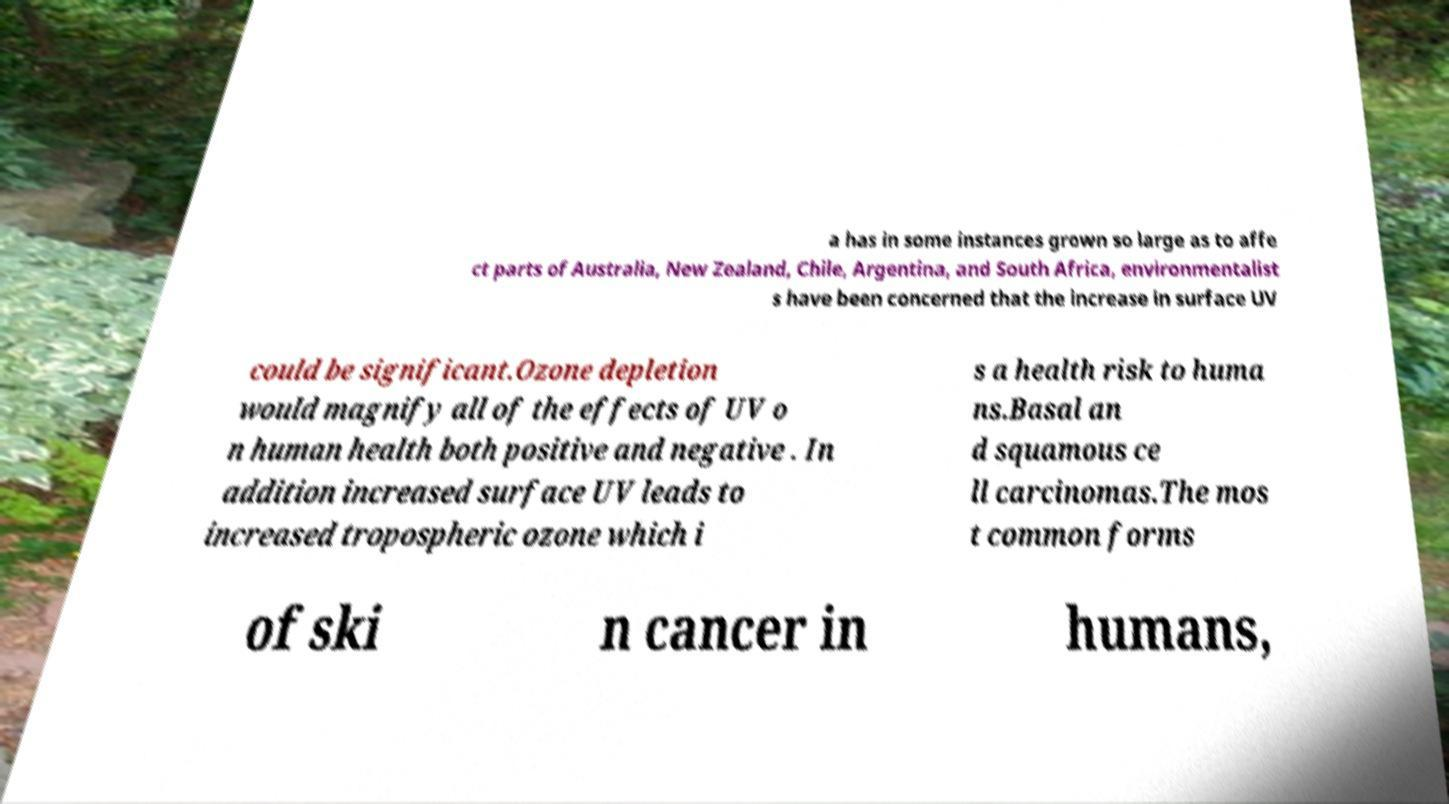Please read and relay the text visible in this image. What does it say? a has in some instances grown so large as to affe ct parts of Australia, New Zealand, Chile, Argentina, and South Africa, environmentalist s have been concerned that the increase in surface UV could be significant.Ozone depletion would magnify all of the effects of UV o n human health both positive and negative . In addition increased surface UV leads to increased tropospheric ozone which i s a health risk to huma ns.Basal an d squamous ce ll carcinomas.The mos t common forms of ski n cancer in humans, 